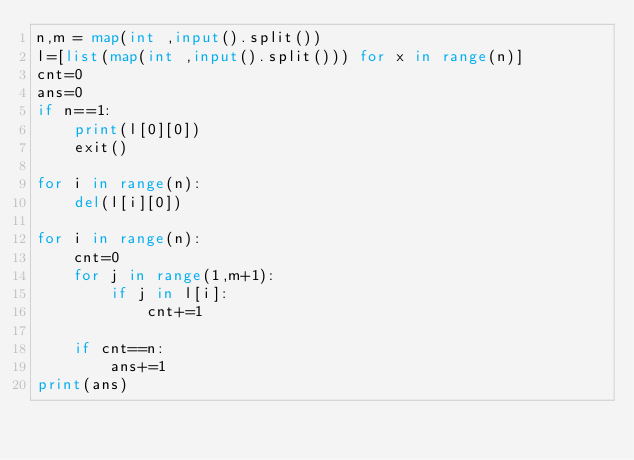<code> <loc_0><loc_0><loc_500><loc_500><_Python_>n,m = map(int ,input().split())
l=[list(map(int ,input().split())) for x in range(n)]
cnt=0
ans=0
if n==1:
    print(l[0][0])
    exit()
    
for i in range(n):
    del(l[i][0])

for i in range(n):
    cnt=0
    for j in range(1,m+1):
        if j in l[i]:
            cnt+=1
    
    if cnt==n:
        ans+=1
print(ans) </code> 